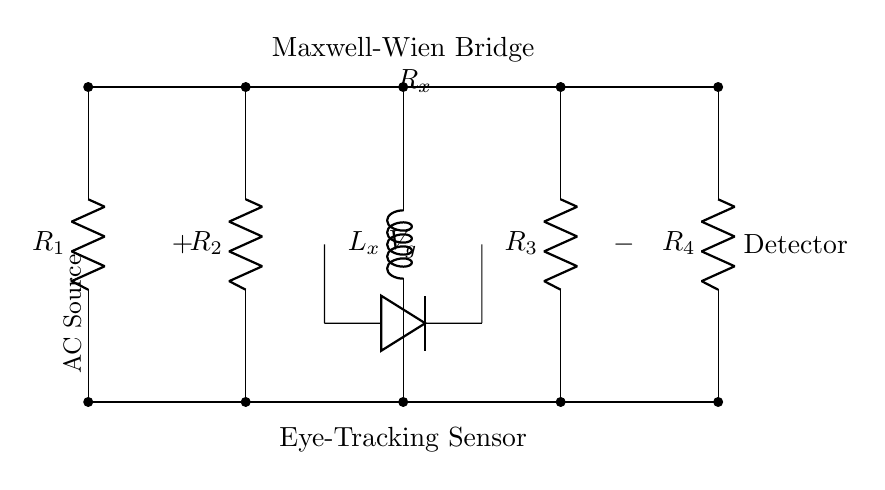What components are present in the Maxwell-Wien bridge circuit? The circuit contains resistors R1, R2, R3, R4, and an inductor Lx, which are essential parts of the Maxwell-Wien bridge used for inductance measurement.
Answer: Resistors and an inductor What is the role of the inductor Lx in this circuit? The inductor Lx is the component whose inductance is being measured, which affects the balance of the bridge and thus the output signal.
Answer: Measure inductance How many resistors are used in this circuit? The circuit has four resistors, which are configured to create a balance in the Maxwell-Wien bridge setup for accurate measurement.
Answer: Four What is the purpose of the AC source in the circuit? The AC source provides alternating current, which is necessary for the operation of the bridge to measure the impedance of Lx at different frequencies.
Answer: Provide alternating current Which component is connected to the detector in this circuit? The circuit diagram shows that the output from the bridge is connected to the detector, which measures the balance condition of the bridge.
Answer: The bridge output Why is the bridge configured with four resistors? The four resistors in the Maxwell-Wien bridge allow for precise adjustments and balancing to minimize the error in the measurement of the unknown inductance.
Answer: For precise balancing What does the notation R_x signify in this circuit? The notation R_x represents the variable resistor in the bridge used to achieve balance, allowing for the measurement of Lx based on the known resistor values.
Answer: Variable resistor 